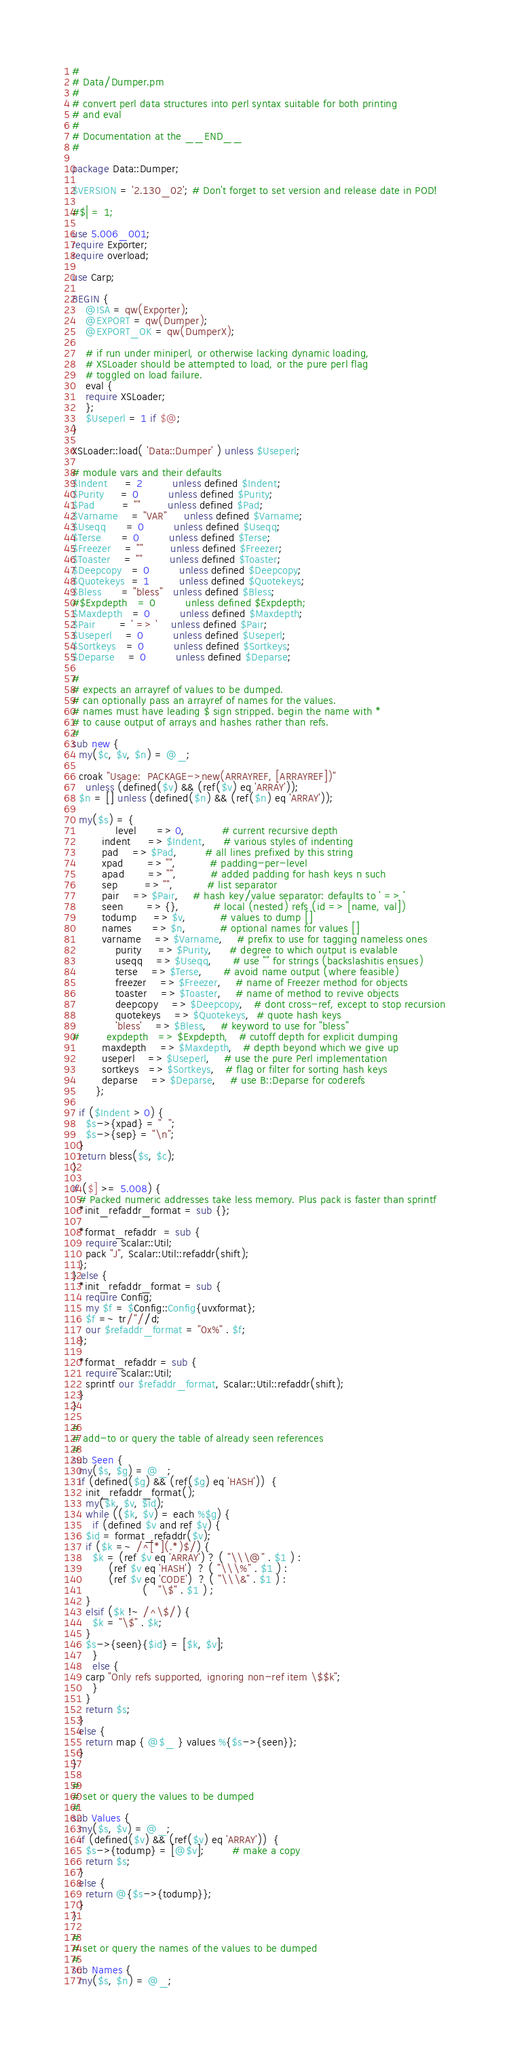Convert code to text. <code><loc_0><loc_0><loc_500><loc_500><_Perl_>#
# Data/Dumper.pm
#
# convert perl data structures into perl syntax suitable for both printing
# and eval
#
# Documentation at the __END__
#

package Data::Dumper;

$VERSION = '2.130_02'; # Don't forget to set version and release date in POD!

#$| = 1;

use 5.006_001;
require Exporter;
require overload;

use Carp;

BEGIN {
    @ISA = qw(Exporter);
    @EXPORT = qw(Dumper);
    @EXPORT_OK = qw(DumperX);

    # if run under miniperl, or otherwise lacking dynamic loading,
    # XSLoader should be attempted to load, or the pure perl flag
    # toggled on load failure.
    eval {
	require XSLoader;
    };
    $Useperl = 1 if $@;
}

XSLoader::load( 'Data::Dumper' ) unless $Useperl;

# module vars and their defaults
$Indent     = 2         unless defined $Indent;
$Purity     = 0         unless defined $Purity;
$Pad        = ""        unless defined $Pad;
$Varname    = "VAR"     unless defined $Varname;
$Useqq      = 0         unless defined $Useqq;
$Terse      = 0         unless defined $Terse;
$Freezer    = ""        unless defined $Freezer;
$Toaster    = ""        unless defined $Toaster;
$Deepcopy   = 0         unless defined $Deepcopy;
$Quotekeys  = 1         unless defined $Quotekeys;
$Bless      = "bless"   unless defined $Bless;
#$Expdepth   = 0         unless defined $Expdepth;
$Maxdepth   = 0         unless defined $Maxdepth;
$Pair       = ' => '    unless defined $Pair;
$Useperl    = 0         unless defined $Useperl;
$Sortkeys   = 0         unless defined $Sortkeys;
$Deparse    = 0         unless defined $Deparse;

#
# expects an arrayref of values to be dumped.
# can optionally pass an arrayref of names for the values.
# names must have leading $ sign stripped. begin the name with *
# to cause output of arrays and hashes rather than refs.
#
sub new {
  my($c, $v, $n) = @_;

  croak "Usage:  PACKAGE->new(ARRAYREF, [ARRAYREF])" 
    unless (defined($v) && (ref($v) eq 'ARRAY'));
  $n = [] unless (defined($n) && (ref($n) eq 'ARRAY'));

  my($s) = { 
             level      => 0,           # current recursive depth
	     indent     => $Indent,     # various styles of indenting
	     pad	=> $Pad,        # all lines prefixed by this string
	     xpad       => "",          # padding-per-level
	     apad       => "",          # added padding for hash keys n such
	     sep        => "",          # list separator
	     pair	=> $Pair,	# hash key/value separator: defaults to ' => '
	     seen       => {},          # local (nested) refs (id => [name, val])
	     todump     => $v,          # values to dump []
	     names      => $n,          # optional names for values []
	     varname    => $Varname,    # prefix to use for tagging nameless ones
             purity     => $Purity,     # degree to which output is evalable
             useqq 	=> $Useqq,      # use "" for strings (backslashitis ensues)
             terse 	=> $Terse,      # avoid name output (where feasible)
             freezer	=> $Freezer,    # name of Freezer method for objects
             toaster	=> $Toaster,    # name of method to revive objects
             deepcopy	=> $Deepcopy,   # dont cross-ref, except to stop recursion
             quotekeys	=> $Quotekeys,  # quote hash keys
             'bless'	=> $Bless,	# keyword to use for "bless"
#	     expdepth   => $Expdepth,   # cutoff depth for explicit dumping
	     maxdepth	=> $Maxdepth,   # depth beyond which we give up
	     useperl    => $Useperl,    # use the pure Perl implementation
	     sortkeys   => $Sortkeys,   # flag or filter for sorting hash keys
	     deparse	=> $Deparse,	# use B::Deparse for coderefs
	   };

  if ($Indent > 0) {
    $s->{xpad} = "  ";
    $s->{sep} = "\n";
  }
  return bless($s, $c);
}

if ($] >= 5.008) {
  # Packed numeric addresses take less memory. Plus pack is faster than sprintf
  *init_refaddr_format = sub {};

  *format_refaddr  = sub {
    require Scalar::Util;
    pack "J", Scalar::Util::refaddr(shift);
  };
} else {
  *init_refaddr_format = sub {
    require Config;
    my $f = $Config::Config{uvxformat};
    $f =~ tr/"//d;
    our $refaddr_format = "0x%" . $f;
  };

  *format_refaddr = sub {
    require Scalar::Util;
    sprintf our $refaddr_format, Scalar::Util::refaddr(shift);
  }
}

#
# add-to or query the table of already seen references
#
sub Seen {
  my($s, $g) = @_;
  if (defined($g) && (ref($g) eq 'HASH'))  {
    init_refaddr_format();
    my($k, $v, $id);
    while (($k, $v) = each %$g) {
      if (defined $v and ref $v) {
	$id = format_refaddr($v);
	if ($k =~ /^[*](.*)$/) {
	  $k = (ref $v eq 'ARRAY') ? ( "\\\@" . $1 ) :
	       (ref $v eq 'HASH')  ? ( "\\\%" . $1 ) :
	       (ref $v eq 'CODE')  ? ( "\\\&" . $1 ) :
				     (   "\$" . $1 ) ;
	}
	elsif ($k !~ /^\$/) {
	  $k = "\$" . $k;
	}
	$s->{seen}{$id} = [$k, $v];
      }
      else {
	carp "Only refs supported, ignoring non-ref item \$$k";
      }
    }
    return $s;
  }
  else {
    return map { @$_ } values %{$s->{seen}};
  }
}

#
# set or query the values to be dumped
#
sub Values {
  my($s, $v) = @_;
  if (defined($v) && (ref($v) eq 'ARRAY'))  {
    $s->{todump} = [@$v];        # make a copy
    return $s;
  }
  else {
    return @{$s->{todump}};
  }
}

#
# set or query the names of the values to be dumped
#
sub Names {
  my($s, $n) = @_;</code> 